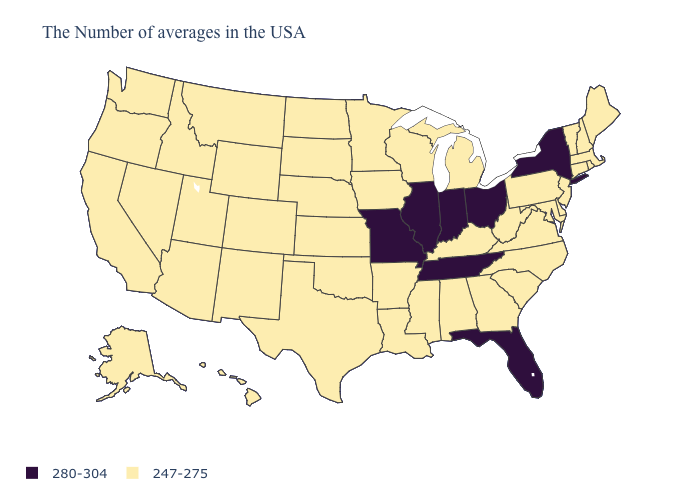Does New York have the highest value in the Northeast?
Answer briefly. Yes. Among the states that border Wisconsin , which have the lowest value?
Quick response, please. Michigan, Minnesota, Iowa. What is the highest value in the USA?
Be succinct. 280-304. What is the value of Alaska?
Concise answer only. 247-275. Which states have the highest value in the USA?
Quick response, please. New York, Ohio, Florida, Indiana, Tennessee, Illinois, Missouri. Which states have the lowest value in the USA?
Write a very short answer. Maine, Massachusetts, Rhode Island, New Hampshire, Vermont, Connecticut, New Jersey, Delaware, Maryland, Pennsylvania, Virginia, North Carolina, South Carolina, West Virginia, Georgia, Michigan, Kentucky, Alabama, Wisconsin, Mississippi, Louisiana, Arkansas, Minnesota, Iowa, Kansas, Nebraska, Oklahoma, Texas, South Dakota, North Dakota, Wyoming, Colorado, New Mexico, Utah, Montana, Arizona, Idaho, Nevada, California, Washington, Oregon, Alaska, Hawaii. Among the states that border West Virginia , which have the lowest value?
Concise answer only. Maryland, Pennsylvania, Virginia, Kentucky. Which states have the lowest value in the MidWest?
Concise answer only. Michigan, Wisconsin, Minnesota, Iowa, Kansas, Nebraska, South Dakota, North Dakota. Name the states that have a value in the range 247-275?
Short answer required. Maine, Massachusetts, Rhode Island, New Hampshire, Vermont, Connecticut, New Jersey, Delaware, Maryland, Pennsylvania, Virginia, North Carolina, South Carolina, West Virginia, Georgia, Michigan, Kentucky, Alabama, Wisconsin, Mississippi, Louisiana, Arkansas, Minnesota, Iowa, Kansas, Nebraska, Oklahoma, Texas, South Dakota, North Dakota, Wyoming, Colorado, New Mexico, Utah, Montana, Arizona, Idaho, Nevada, California, Washington, Oregon, Alaska, Hawaii. Does Ohio have the highest value in the USA?
Short answer required. Yes. What is the value of Hawaii?
Quick response, please. 247-275. What is the value of Vermont?
Short answer required. 247-275. What is the value of Montana?
Be succinct. 247-275. Among the states that border Iowa , which have the lowest value?
Be succinct. Wisconsin, Minnesota, Nebraska, South Dakota. What is the value of Arizona?
Concise answer only. 247-275. 